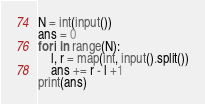<code> <loc_0><loc_0><loc_500><loc_500><_Python_>N = int(input())
ans = 0
for i in range(N):
    l, r = map(int, input().split())
    ans += r - l +1
print(ans)</code> 